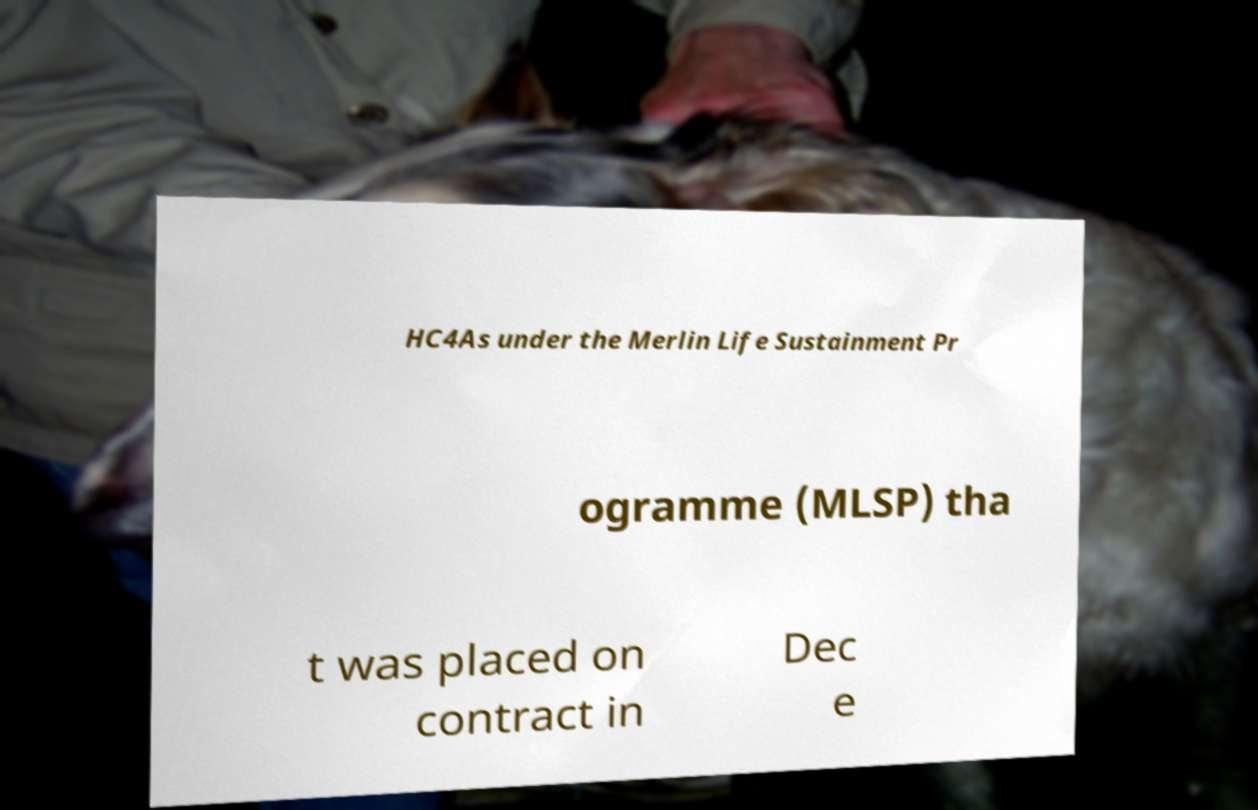What messages or text are displayed in this image? I need them in a readable, typed format. HC4As under the Merlin Life Sustainment Pr ogramme (MLSP) tha t was placed on contract in Dec e 